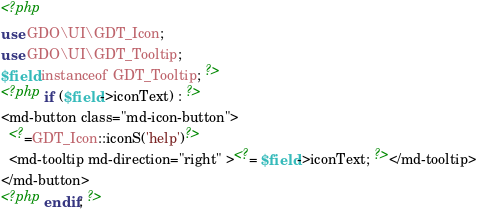Convert code to text. <code><loc_0><loc_0><loc_500><loc_500><_PHP_><?php
use GDO\UI\GDT_Icon;
use GDO\UI\GDT_Tooltip;
$field instanceof GDT_Tooltip; ?>
<?php if ($field->iconText) : ?>
<md-button class="md-icon-button">
  <?=GDT_Icon::iconS('help')?>
  <md-tooltip md-direction="right" ><?= $field->iconText; ?></md-tooltip>
</md-button>
<?php endif; ?></code> 